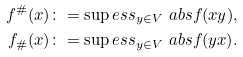Convert formula to latex. <formula><loc_0><loc_0><loc_500><loc_500>f ^ { \# } ( x ) & \colon = \sup e s s _ { y \in V } \ a b s { f ( x y ) } , \\ f _ { \# } ( x ) & \colon = \sup e s s _ { y \in V } \ a b s { f ( y x ) } .</formula> 